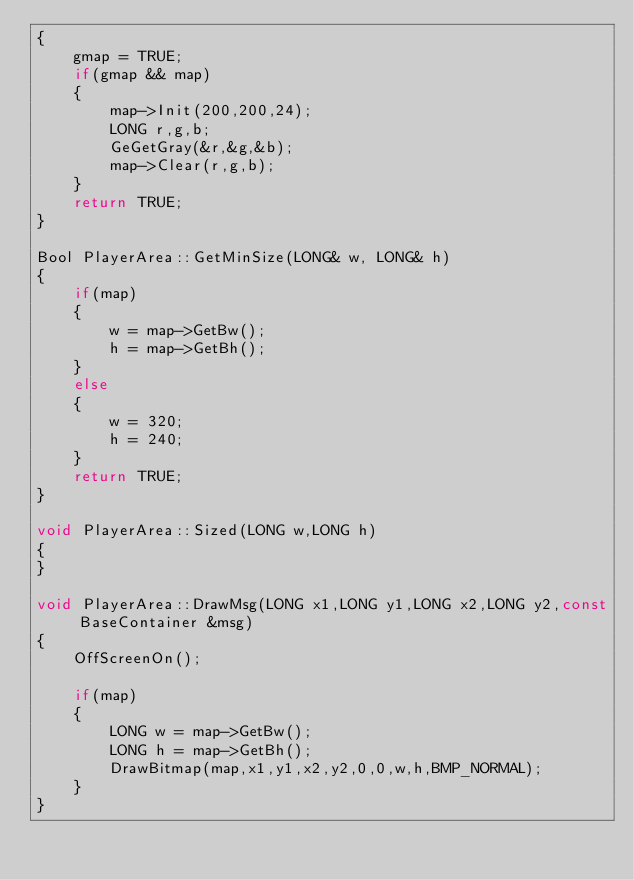<code> <loc_0><loc_0><loc_500><loc_500><_C++_>{
	gmap = TRUE;
	if(gmap && map)
	{
		map->Init(200,200,24);
		LONG r,g,b;
		GeGetGray(&r,&g,&b);
		map->Clear(r,g,b);
	}
	return TRUE;
}

Bool PlayerArea::GetMinSize(LONG& w, LONG& h)
{	
	if(map)
	{
		w = map->GetBw();
		h = map->GetBh();
	}
	else
	{
		w = 320;
		h = 240;
	}
	return TRUE;
}

void PlayerArea::Sized(LONG w,LONG h)
{
}

void PlayerArea::DrawMsg(LONG x1,LONG y1,LONG x2,LONG y2,const BaseContainer &msg)
{
	OffScreenOn();
	
	if(map)
	{
		LONG w = map->GetBw();
		LONG h = map->GetBh();
		DrawBitmap(map,x1,y1,x2,y2,0,0,w,h,BMP_NORMAL);
	}
}
</code> 